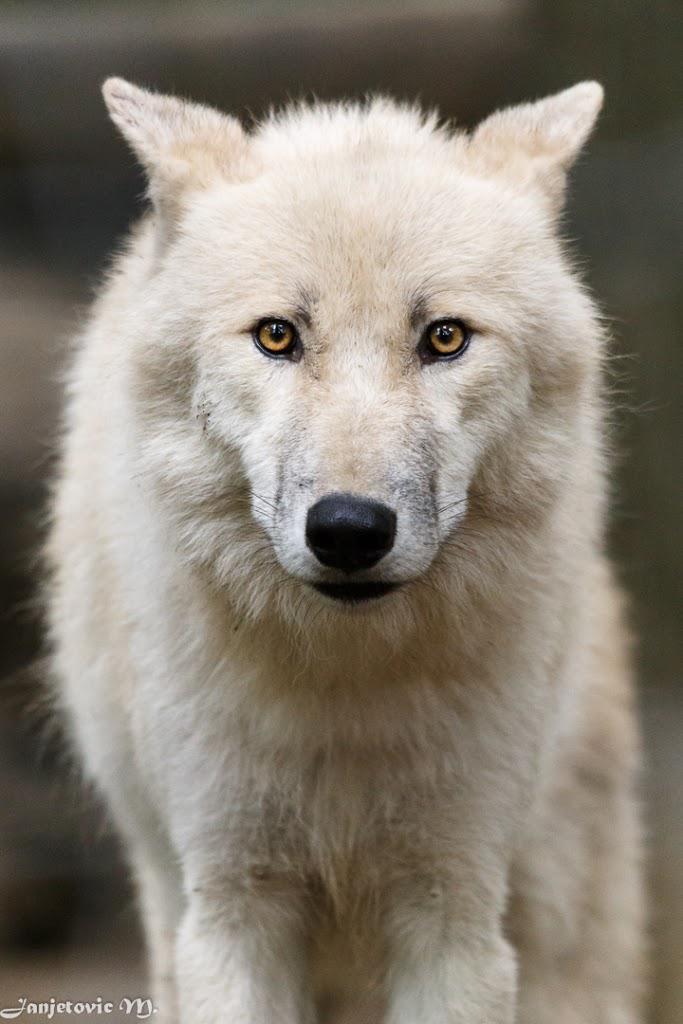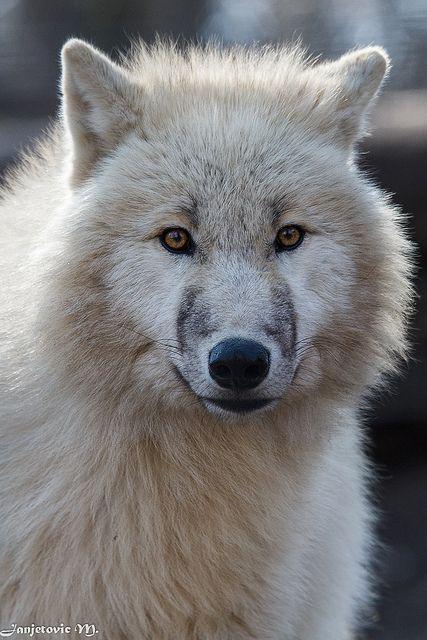The first image is the image on the left, the second image is the image on the right. Given the left and right images, does the statement "profile of wolves faces only facing the camera" hold true? Answer yes or no. Yes. 